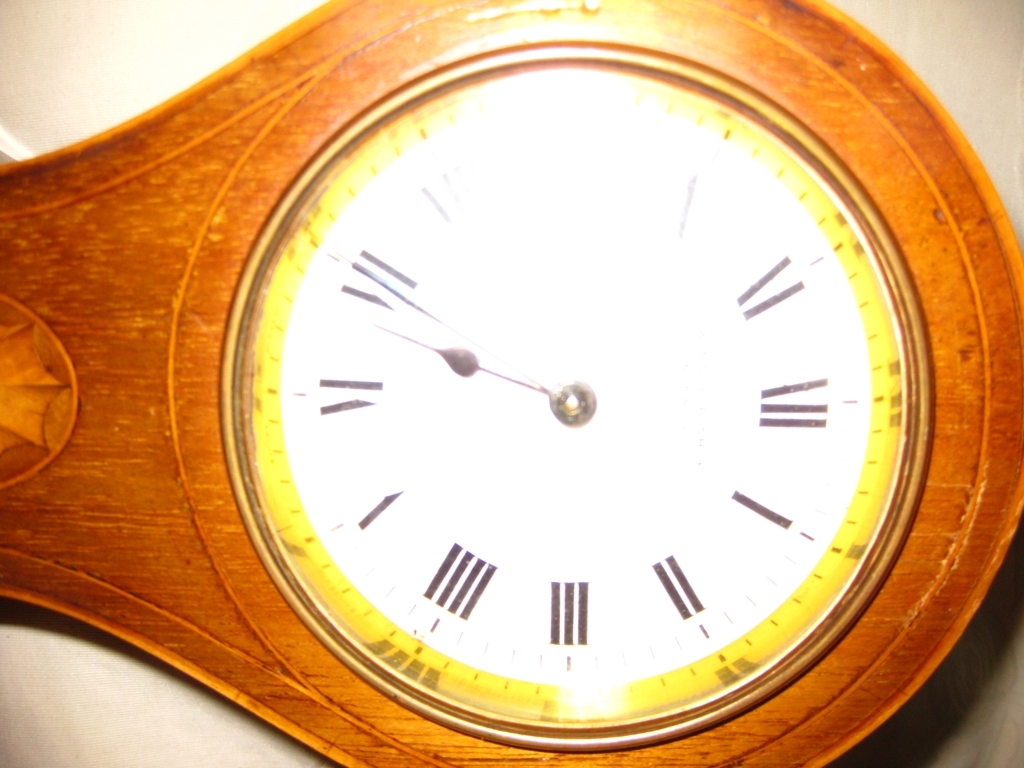What sort of setting would this clock fit into appropriately? This clock would fit well into settings that appreciate antique or vintage decor. Think of a cozy study room, an elegant living room with classic furniture, or perhaps a library filled with books where the warmth of the wooden clock complements the overall ambiance. 